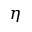<formula> <loc_0><loc_0><loc_500><loc_500>\eta</formula> 